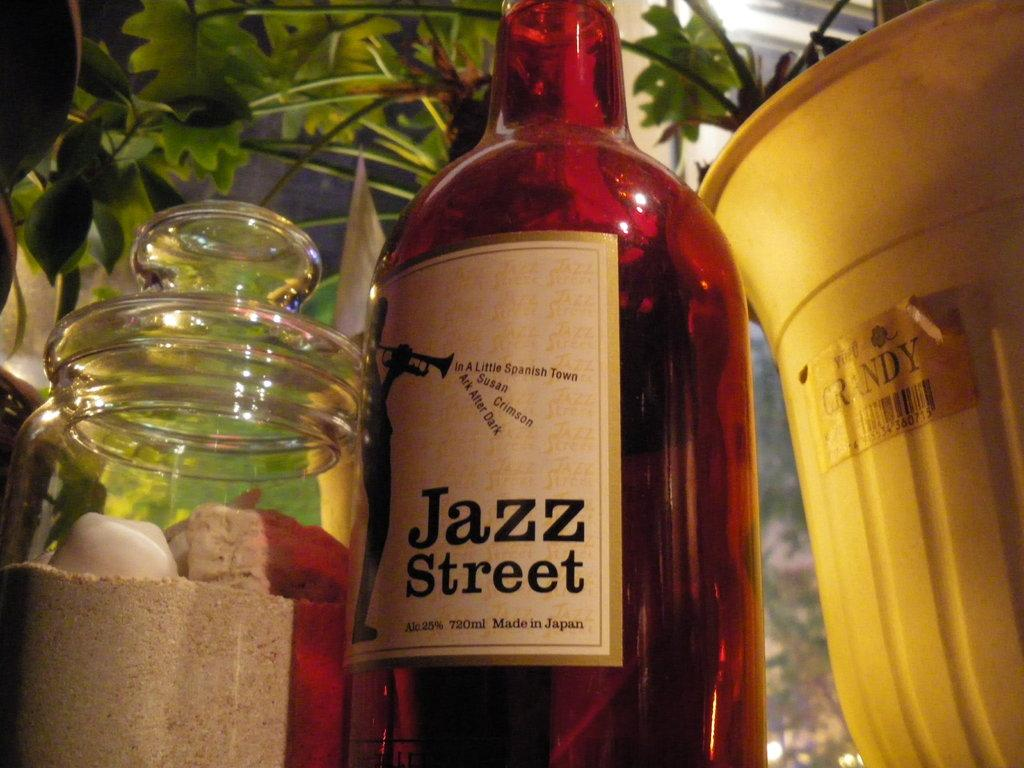<image>
Create a compact narrative representing the image presented. A bottle of Jazz Street is next to a bucket with the word Grandy on it 